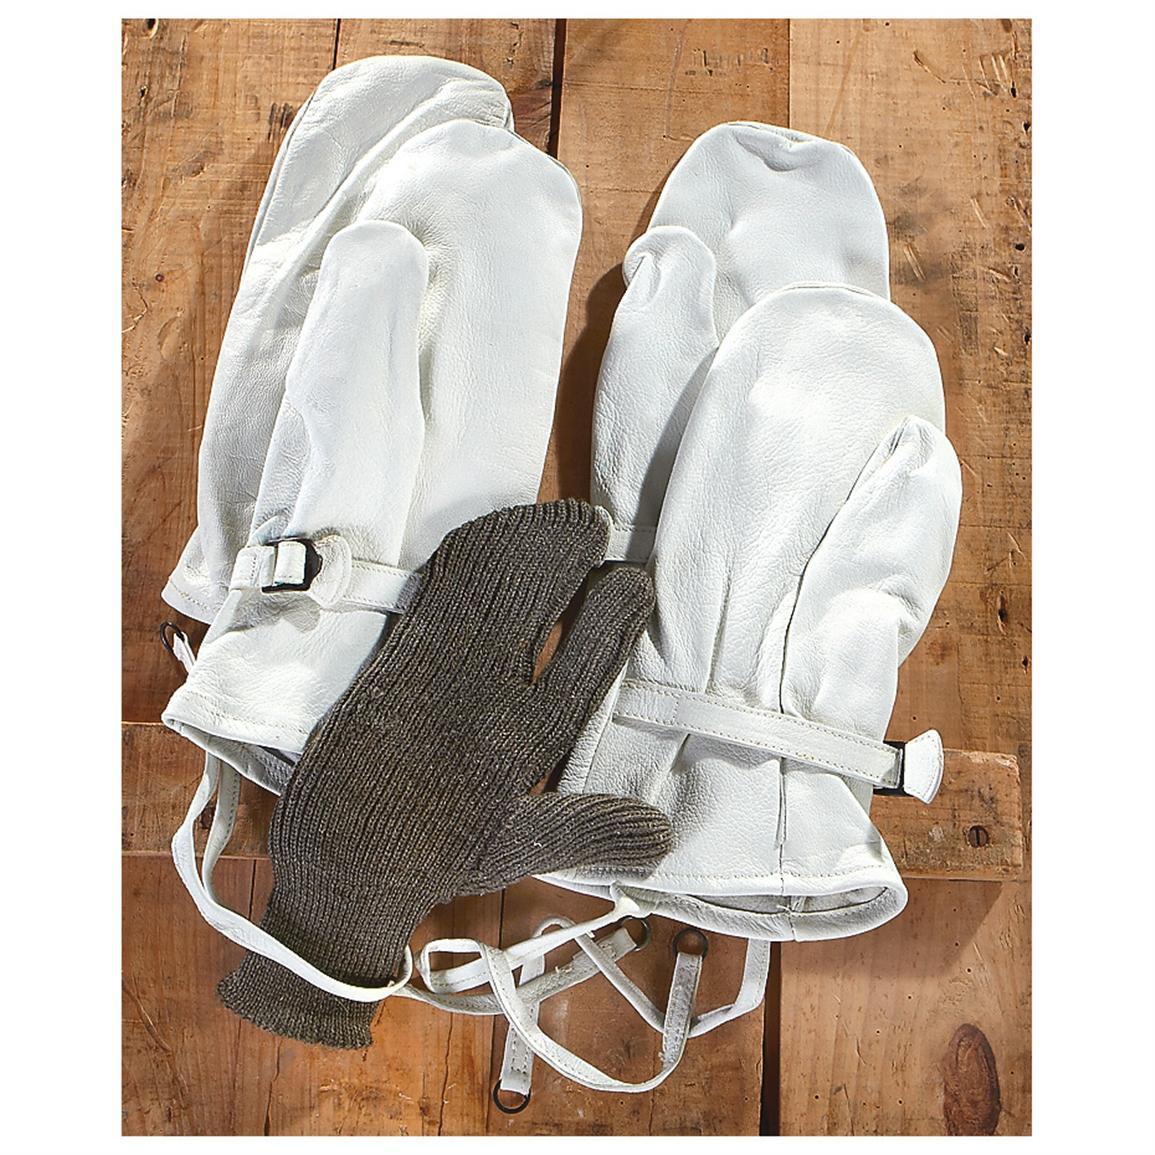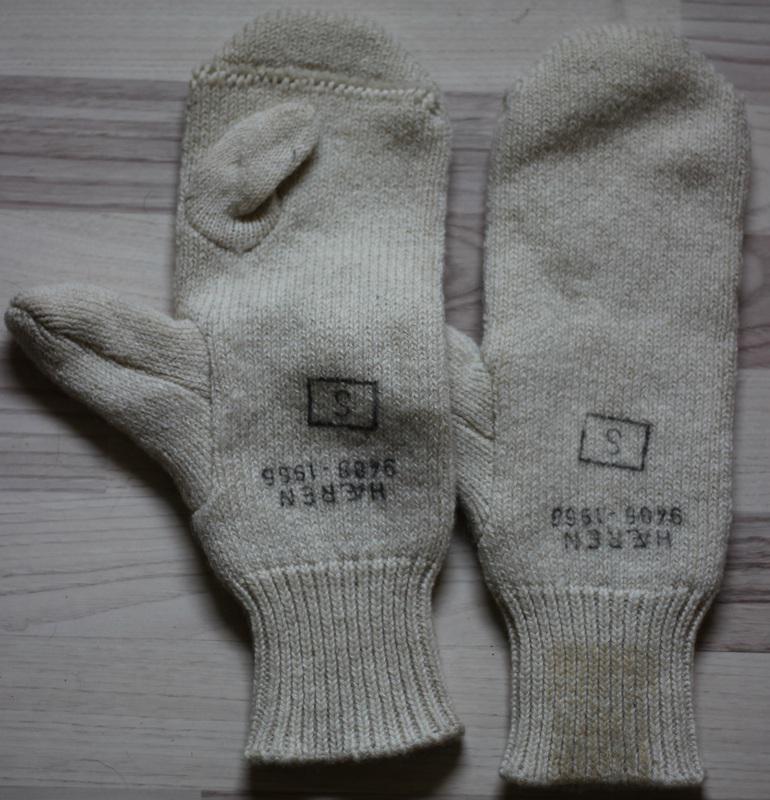The first image is the image on the left, the second image is the image on the right. Assess this claim about the two images: "An image includes a brown knitted hybrid of a mitten and a glove.". Correct or not? Answer yes or no. Yes. 